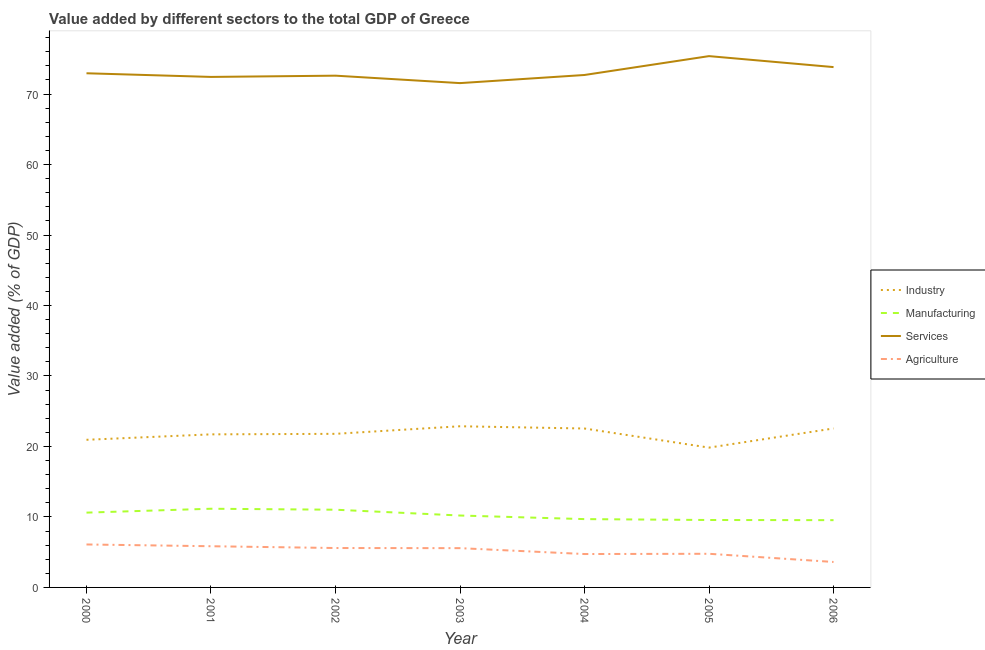Does the line corresponding to value added by manufacturing sector intersect with the line corresponding to value added by industrial sector?
Offer a terse response. No. Is the number of lines equal to the number of legend labels?
Provide a short and direct response. Yes. What is the value added by services sector in 2006?
Your response must be concise. 73.83. Across all years, what is the maximum value added by manufacturing sector?
Your response must be concise. 11.17. Across all years, what is the minimum value added by manufacturing sector?
Offer a terse response. 9.55. In which year was the value added by industrial sector maximum?
Offer a very short reply. 2003. In which year was the value added by manufacturing sector minimum?
Ensure brevity in your answer.  2006. What is the total value added by manufacturing sector in the graph?
Your response must be concise. 71.82. What is the difference between the value added by manufacturing sector in 2000 and that in 2001?
Your response must be concise. -0.55. What is the difference between the value added by manufacturing sector in 2000 and the value added by industrial sector in 2005?
Keep it short and to the point. -9.22. What is the average value added by industrial sector per year?
Provide a short and direct response. 21.75. In the year 2004, what is the difference between the value added by industrial sector and value added by manufacturing sector?
Provide a succinct answer. 12.85. What is the ratio of the value added by manufacturing sector in 2000 to that in 2002?
Provide a short and direct response. 0.96. What is the difference between the highest and the second highest value added by manufacturing sector?
Make the answer very short. 0.14. What is the difference between the highest and the lowest value added by manufacturing sector?
Offer a very short reply. 1.62. In how many years, is the value added by industrial sector greater than the average value added by industrial sector taken over all years?
Make the answer very short. 4. Is it the case that in every year, the sum of the value added by industrial sector and value added by manufacturing sector is greater than the value added by services sector?
Provide a succinct answer. No. Does the value added by services sector monotonically increase over the years?
Keep it short and to the point. No. How many lines are there?
Your answer should be compact. 4. How many years are there in the graph?
Make the answer very short. 7. What is the difference between two consecutive major ticks on the Y-axis?
Keep it short and to the point. 10. Are the values on the major ticks of Y-axis written in scientific E-notation?
Make the answer very short. No. Where does the legend appear in the graph?
Keep it short and to the point. Center right. What is the title of the graph?
Offer a terse response. Value added by different sectors to the total GDP of Greece. What is the label or title of the Y-axis?
Offer a terse response. Value added (% of GDP). What is the Value added (% of GDP) in Industry in 2000?
Provide a short and direct response. 20.95. What is the Value added (% of GDP) in Manufacturing in 2000?
Offer a terse response. 10.61. What is the Value added (% of GDP) in Services in 2000?
Your answer should be very brief. 72.96. What is the Value added (% of GDP) in Agriculture in 2000?
Offer a terse response. 6.1. What is the Value added (% of GDP) of Industry in 2001?
Give a very brief answer. 21.72. What is the Value added (% of GDP) of Manufacturing in 2001?
Make the answer very short. 11.17. What is the Value added (% of GDP) in Services in 2001?
Keep it short and to the point. 72.44. What is the Value added (% of GDP) of Agriculture in 2001?
Make the answer very short. 5.84. What is the Value added (% of GDP) in Industry in 2002?
Your answer should be very brief. 21.79. What is the Value added (% of GDP) in Manufacturing in 2002?
Ensure brevity in your answer.  11.03. What is the Value added (% of GDP) of Services in 2002?
Your response must be concise. 72.61. What is the Value added (% of GDP) in Agriculture in 2002?
Give a very brief answer. 5.59. What is the Value added (% of GDP) in Industry in 2003?
Provide a short and direct response. 22.87. What is the Value added (% of GDP) in Manufacturing in 2003?
Your answer should be compact. 10.2. What is the Value added (% of GDP) of Services in 2003?
Give a very brief answer. 71.56. What is the Value added (% of GDP) in Agriculture in 2003?
Make the answer very short. 5.57. What is the Value added (% of GDP) in Industry in 2004?
Your answer should be very brief. 22.55. What is the Value added (% of GDP) in Manufacturing in 2004?
Your answer should be compact. 9.69. What is the Value added (% of GDP) of Services in 2004?
Give a very brief answer. 72.71. What is the Value added (% of GDP) in Agriculture in 2004?
Keep it short and to the point. 4.74. What is the Value added (% of GDP) of Industry in 2005?
Ensure brevity in your answer.  19.84. What is the Value added (% of GDP) in Manufacturing in 2005?
Provide a short and direct response. 9.57. What is the Value added (% of GDP) of Services in 2005?
Provide a succinct answer. 75.39. What is the Value added (% of GDP) in Agriculture in 2005?
Make the answer very short. 4.77. What is the Value added (% of GDP) of Industry in 2006?
Make the answer very short. 22.56. What is the Value added (% of GDP) in Manufacturing in 2006?
Offer a very short reply. 9.55. What is the Value added (% of GDP) of Services in 2006?
Your answer should be very brief. 73.83. What is the Value added (% of GDP) in Agriculture in 2006?
Offer a terse response. 3.61. Across all years, what is the maximum Value added (% of GDP) of Industry?
Keep it short and to the point. 22.87. Across all years, what is the maximum Value added (% of GDP) of Manufacturing?
Provide a succinct answer. 11.17. Across all years, what is the maximum Value added (% of GDP) in Services?
Ensure brevity in your answer.  75.39. Across all years, what is the maximum Value added (% of GDP) of Agriculture?
Keep it short and to the point. 6.1. Across all years, what is the minimum Value added (% of GDP) in Industry?
Ensure brevity in your answer.  19.84. Across all years, what is the minimum Value added (% of GDP) in Manufacturing?
Your answer should be compact. 9.55. Across all years, what is the minimum Value added (% of GDP) of Services?
Your answer should be very brief. 71.56. Across all years, what is the minimum Value added (% of GDP) in Agriculture?
Offer a terse response. 3.61. What is the total Value added (% of GDP) in Industry in the graph?
Offer a terse response. 152.27. What is the total Value added (% of GDP) of Manufacturing in the graph?
Your answer should be compact. 71.82. What is the total Value added (% of GDP) in Services in the graph?
Your answer should be compact. 511.5. What is the total Value added (% of GDP) of Agriculture in the graph?
Ensure brevity in your answer.  36.23. What is the difference between the Value added (% of GDP) of Industry in 2000 and that in 2001?
Provide a succinct answer. -0.77. What is the difference between the Value added (% of GDP) of Manufacturing in 2000 and that in 2001?
Give a very brief answer. -0.55. What is the difference between the Value added (% of GDP) in Services in 2000 and that in 2001?
Offer a very short reply. 0.52. What is the difference between the Value added (% of GDP) of Agriculture in 2000 and that in 2001?
Give a very brief answer. 0.25. What is the difference between the Value added (% of GDP) of Industry in 2000 and that in 2002?
Ensure brevity in your answer.  -0.85. What is the difference between the Value added (% of GDP) in Manufacturing in 2000 and that in 2002?
Ensure brevity in your answer.  -0.41. What is the difference between the Value added (% of GDP) in Services in 2000 and that in 2002?
Keep it short and to the point. 0.34. What is the difference between the Value added (% of GDP) in Agriculture in 2000 and that in 2002?
Make the answer very short. 0.5. What is the difference between the Value added (% of GDP) of Industry in 2000 and that in 2003?
Offer a terse response. -1.92. What is the difference between the Value added (% of GDP) in Manufacturing in 2000 and that in 2003?
Your response must be concise. 0.41. What is the difference between the Value added (% of GDP) in Services in 2000 and that in 2003?
Offer a terse response. 1.4. What is the difference between the Value added (% of GDP) in Agriculture in 2000 and that in 2003?
Give a very brief answer. 0.52. What is the difference between the Value added (% of GDP) in Industry in 2000 and that in 2004?
Your answer should be compact. -1.6. What is the difference between the Value added (% of GDP) in Manufacturing in 2000 and that in 2004?
Your response must be concise. 0.92. What is the difference between the Value added (% of GDP) in Services in 2000 and that in 2004?
Your response must be concise. 0.24. What is the difference between the Value added (% of GDP) in Agriculture in 2000 and that in 2004?
Your answer should be compact. 1.36. What is the difference between the Value added (% of GDP) in Industry in 2000 and that in 2005?
Make the answer very short. 1.11. What is the difference between the Value added (% of GDP) in Manufacturing in 2000 and that in 2005?
Provide a short and direct response. 1.05. What is the difference between the Value added (% of GDP) of Services in 2000 and that in 2005?
Ensure brevity in your answer.  -2.43. What is the difference between the Value added (% of GDP) of Agriculture in 2000 and that in 2005?
Offer a terse response. 1.32. What is the difference between the Value added (% of GDP) of Industry in 2000 and that in 2006?
Your answer should be compact. -1.61. What is the difference between the Value added (% of GDP) of Manufacturing in 2000 and that in 2006?
Your response must be concise. 1.07. What is the difference between the Value added (% of GDP) of Services in 2000 and that in 2006?
Keep it short and to the point. -0.87. What is the difference between the Value added (% of GDP) of Agriculture in 2000 and that in 2006?
Your response must be concise. 2.48. What is the difference between the Value added (% of GDP) of Industry in 2001 and that in 2002?
Ensure brevity in your answer.  -0.07. What is the difference between the Value added (% of GDP) in Manufacturing in 2001 and that in 2002?
Offer a very short reply. 0.14. What is the difference between the Value added (% of GDP) in Services in 2001 and that in 2002?
Your answer should be very brief. -0.18. What is the difference between the Value added (% of GDP) of Agriculture in 2001 and that in 2002?
Offer a very short reply. 0.25. What is the difference between the Value added (% of GDP) in Industry in 2001 and that in 2003?
Keep it short and to the point. -1.15. What is the difference between the Value added (% of GDP) of Manufacturing in 2001 and that in 2003?
Keep it short and to the point. 0.96. What is the difference between the Value added (% of GDP) of Services in 2001 and that in 2003?
Ensure brevity in your answer.  0.88. What is the difference between the Value added (% of GDP) in Agriculture in 2001 and that in 2003?
Provide a short and direct response. 0.27. What is the difference between the Value added (% of GDP) of Industry in 2001 and that in 2004?
Provide a short and direct response. -0.83. What is the difference between the Value added (% of GDP) of Manufacturing in 2001 and that in 2004?
Give a very brief answer. 1.47. What is the difference between the Value added (% of GDP) of Services in 2001 and that in 2004?
Your response must be concise. -0.28. What is the difference between the Value added (% of GDP) of Agriculture in 2001 and that in 2004?
Keep it short and to the point. 1.11. What is the difference between the Value added (% of GDP) of Industry in 2001 and that in 2005?
Offer a very short reply. 1.88. What is the difference between the Value added (% of GDP) of Manufacturing in 2001 and that in 2005?
Your answer should be very brief. 1.6. What is the difference between the Value added (% of GDP) in Services in 2001 and that in 2005?
Make the answer very short. -2.95. What is the difference between the Value added (% of GDP) of Agriculture in 2001 and that in 2005?
Your answer should be compact. 1.07. What is the difference between the Value added (% of GDP) of Industry in 2001 and that in 2006?
Keep it short and to the point. -0.84. What is the difference between the Value added (% of GDP) in Manufacturing in 2001 and that in 2006?
Provide a short and direct response. 1.62. What is the difference between the Value added (% of GDP) in Services in 2001 and that in 2006?
Make the answer very short. -1.4. What is the difference between the Value added (% of GDP) in Agriculture in 2001 and that in 2006?
Your answer should be compact. 2.23. What is the difference between the Value added (% of GDP) of Industry in 2002 and that in 2003?
Provide a short and direct response. -1.07. What is the difference between the Value added (% of GDP) of Manufacturing in 2002 and that in 2003?
Your answer should be very brief. 0.82. What is the difference between the Value added (% of GDP) in Services in 2002 and that in 2003?
Your answer should be very brief. 1.06. What is the difference between the Value added (% of GDP) in Agriculture in 2002 and that in 2003?
Ensure brevity in your answer.  0.02. What is the difference between the Value added (% of GDP) in Industry in 2002 and that in 2004?
Make the answer very short. -0.76. What is the difference between the Value added (% of GDP) in Manufacturing in 2002 and that in 2004?
Your response must be concise. 1.33. What is the difference between the Value added (% of GDP) of Services in 2002 and that in 2004?
Provide a succinct answer. -0.1. What is the difference between the Value added (% of GDP) of Agriculture in 2002 and that in 2004?
Your answer should be very brief. 0.85. What is the difference between the Value added (% of GDP) of Industry in 2002 and that in 2005?
Ensure brevity in your answer.  1.96. What is the difference between the Value added (% of GDP) in Manufacturing in 2002 and that in 2005?
Offer a very short reply. 1.46. What is the difference between the Value added (% of GDP) in Services in 2002 and that in 2005?
Give a very brief answer. -2.77. What is the difference between the Value added (% of GDP) in Agriculture in 2002 and that in 2005?
Your answer should be very brief. 0.82. What is the difference between the Value added (% of GDP) in Industry in 2002 and that in 2006?
Your answer should be compact. -0.76. What is the difference between the Value added (% of GDP) of Manufacturing in 2002 and that in 2006?
Give a very brief answer. 1.48. What is the difference between the Value added (% of GDP) of Services in 2002 and that in 2006?
Ensure brevity in your answer.  -1.22. What is the difference between the Value added (% of GDP) in Agriculture in 2002 and that in 2006?
Ensure brevity in your answer.  1.98. What is the difference between the Value added (% of GDP) in Industry in 2003 and that in 2004?
Offer a terse response. 0.32. What is the difference between the Value added (% of GDP) of Manufacturing in 2003 and that in 2004?
Offer a terse response. 0.51. What is the difference between the Value added (% of GDP) of Services in 2003 and that in 2004?
Make the answer very short. -1.15. What is the difference between the Value added (% of GDP) in Agriculture in 2003 and that in 2004?
Your response must be concise. 0.83. What is the difference between the Value added (% of GDP) in Industry in 2003 and that in 2005?
Your answer should be very brief. 3.03. What is the difference between the Value added (% of GDP) in Manufacturing in 2003 and that in 2005?
Your answer should be compact. 0.64. What is the difference between the Value added (% of GDP) of Services in 2003 and that in 2005?
Give a very brief answer. -3.83. What is the difference between the Value added (% of GDP) in Agriculture in 2003 and that in 2005?
Make the answer very short. 0.8. What is the difference between the Value added (% of GDP) of Industry in 2003 and that in 2006?
Make the answer very short. 0.31. What is the difference between the Value added (% of GDP) of Manufacturing in 2003 and that in 2006?
Your answer should be very brief. 0.66. What is the difference between the Value added (% of GDP) of Services in 2003 and that in 2006?
Provide a succinct answer. -2.27. What is the difference between the Value added (% of GDP) in Agriculture in 2003 and that in 2006?
Provide a succinct answer. 1.96. What is the difference between the Value added (% of GDP) of Industry in 2004 and that in 2005?
Your response must be concise. 2.71. What is the difference between the Value added (% of GDP) of Manufacturing in 2004 and that in 2005?
Offer a very short reply. 0.13. What is the difference between the Value added (% of GDP) of Services in 2004 and that in 2005?
Offer a very short reply. -2.68. What is the difference between the Value added (% of GDP) in Agriculture in 2004 and that in 2005?
Give a very brief answer. -0.03. What is the difference between the Value added (% of GDP) in Industry in 2004 and that in 2006?
Offer a terse response. -0.01. What is the difference between the Value added (% of GDP) in Manufacturing in 2004 and that in 2006?
Ensure brevity in your answer.  0.15. What is the difference between the Value added (% of GDP) in Services in 2004 and that in 2006?
Your answer should be very brief. -1.12. What is the difference between the Value added (% of GDP) of Agriculture in 2004 and that in 2006?
Offer a terse response. 1.13. What is the difference between the Value added (% of GDP) in Industry in 2005 and that in 2006?
Give a very brief answer. -2.72. What is the difference between the Value added (% of GDP) of Manufacturing in 2005 and that in 2006?
Your answer should be very brief. 0.02. What is the difference between the Value added (% of GDP) in Services in 2005 and that in 2006?
Provide a short and direct response. 1.56. What is the difference between the Value added (% of GDP) in Agriculture in 2005 and that in 2006?
Ensure brevity in your answer.  1.16. What is the difference between the Value added (% of GDP) of Industry in 2000 and the Value added (% of GDP) of Manufacturing in 2001?
Your answer should be very brief. 9.78. What is the difference between the Value added (% of GDP) of Industry in 2000 and the Value added (% of GDP) of Services in 2001?
Provide a succinct answer. -51.49. What is the difference between the Value added (% of GDP) in Industry in 2000 and the Value added (% of GDP) in Agriculture in 2001?
Your answer should be very brief. 15.1. What is the difference between the Value added (% of GDP) of Manufacturing in 2000 and the Value added (% of GDP) of Services in 2001?
Offer a very short reply. -61.82. What is the difference between the Value added (% of GDP) in Manufacturing in 2000 and the Value added (% of GDP) in Agriculture in 2001?
Give a very brief answer. 4.77. What is the difference between the Value added (% of GDP) in Services in 2000 and the Value added (% of GDP) in Agriculture in 2001?
Offer a terse response. 67.11. What is the difference between the Value added (% of GDP) in Industry in 2000 and the Value added (% of GDP) in Manufacturing in 2002?
Make the answer very short. 9.92. What is the difference between the Value added (% of GDP) of Industry in 2000 and the Value added (% of GDP) of Services in 2002?
Offer a very short reply. -51.67. What is the difference between the Value added (% of GDP) of Industry in 2000 and the Value added (% of GDP) of Agriculture in 2002?
Your answer should be very brief. 15.36. What is the difference between the Value added (% of GDP) in Manufacturing in 2000 and the Value added (% of GDP) in Services in 2002?
Your answer should be very brief. -62. What is the difference between the Value added (% of GDP) in Manufacturing in 2000 and the Value added (% of GDP) in Agriculture in 2002?
Your response must be concise. 5.02. What is the difference between the Value added (% of GDP) in Services in 2000 and the Value added (% of GDP) in Agriculture in 2002?
Make the answer very short. 67.36. What is the difference between the Value added (% of GDP) of Industry in 2000 and the Value added (% of GDP) of Manufacturing in 2003?
Offer a terse response. 10.74. What is the difference between the Value added (% of GDP) in Industry in 2000 and the Value added (% of GDP) in Services in 2003?
Provide a succinct answer. -50.61. What is the difference between the Value added (% of GDP) in Industry in 2000 and the Value added (% of GDP) in Agriculture in 2003?
Keep it short and to the point. 15.38. What is the difference between the Value added (% of GDP) of Manufacturing in 2000 and the Value added (% of GDP) of Services in 2003?
Keep it short and to the point. -60.94. What is the difference between the Value added (% of GDP) in Manufacturing in 2000 and the Value added (% of GDP) in Agriculture in 2003?
Your answer should be compact. 5.04. What is the difference between the Value added (% of GDP) in Services in 2000 and the Value added (% of GDP) in Agriculture in 2003?
Keep it short and to the point. 67.38. What is the difference between the Value added (% of GDP) of Industry in 2000 and the Value added (% of GDP) of Manufacturing in 2004?
Your answer should be compact. 11.25. What is the difference between the Value added (% of GDP) of Industry in 2000 and the Value added (% of GDP) of Services in 2004?
Provide a short and direct response. -51.76. What is the difference between the Value added (% of GDP) in Industry in 2000 and the Value added (% of GDP) in Agriculture in 2004?
Your answer should be very brief. 16.21. What is the difference between the Value added (% of GDP) of Manufacturing in 2000 and the Value added (% of GDP) of Services in 2004?
Make the answer very short. -62.1. What is the difference between the Value added (% of GDP) of Manufacturing in 2000 and the Value added (% of GDP) of Agriculture in 2004?
Keep it short and to the point. 5.88. What is the difference between the Value added (% of GDP) of Services in 2000 and the Value added (% of GDP) of Agriculture in 2004?
Provide a short and direct response. 68.22. What is the difference between the Value added (% of GDP) of Industry in 2000 and the Value added (% of GDP) of Manufacturing in 2005?
Make the answer very short. 11.38. What is the difference between the Value added (% of GDP) in Industry in 2000 and the Value added (% of GDP) in Services in 2005?
Give a very brief answer. -54.44. What is the difference between the Value added (% of GDP) of Industry in 2000 and the Value added (% of GDP) of Agriculture in 2005?
Your response must be concise. 16.17. What is the difference between the Value added (% of GDP) in Manufacturing in 2000 and the Value added (% of GDP) in Services in 2005?
Keep it short and to the point. -64.77. What is the difference between the Value added (% of GDP) in Manufacturing in 2000 and the Value added (% of GDP) in Agriculture in 2005?
Provide a short and direct response. 5.84. What is the difference between the Value added (% of GDP) in Services in 2000 and the Value added (% of GDP) in Agriculture in 2005?
Ensure brevity in your answer.  68.18. What is the difference between the Value added (% of GDP) in Industry in 2000 and the Value added (% of GDP) in Manufacturing in 2006?
Provide a short and direct response. 11.4. What is the difference between the Value added (% of GDP) of Industry in 2000 and the Value added (% of GDP) of Services in 2006?
Your response must be concise. -52.88. What is the difference between the Value added (% of GDP) in Industry in 2000 and the Value added (% of GDP) in Agriculture in 2006?
Give a very brief answer. 17.34. What is the difference between the Value added (% of GDP) of Manufacturing in 2000 and the Value added (% of GDP) of Services in 2006?
Make the answer very short. -63.22. What is the difference between the Value added (% of GDP) in Manufacturing in 2000 and the Value added (% of GDP) in Agriculture in 2006?
Keep it short and to the point. 7. What is the difference between the Value added (% of GDP) of Services in 2000 and the Value added (% of GDP) of Agriculture in 2006?
Your response must be concise. 69.34. What is the difference between the Value added (% of GDP) of Industry in 2001 and the Value added (% of GDP) of Manufacturing in 2002?
Your answer should be very brief. 10.69. What is the difference between the Value added (% of GDP) in Industry in 2001 and the Value added (% of GDP) in Services in 2002?
Your response must be concise. -50.9. What is the difference between the Value added (% of GDP) in Industry in 2001 and the Value added (% of GDP) in Agriculture in 2002?
Provide a short and direct response. 16.13. What is the difference between the Value added (% of GDP) of Manufacturing in 2001 and the Value added (% of GDP) of Services in 2002?
Your answer should be compact. -61.45. What is the difference between the Value added (% of GDP) in Manufacturing in 2001 and the Value added (% of GDP) in Agriculture in 2002?
Your answer should be very brief. 5.57. What is the difference between the Value added (% of GDP) in Services in 2001 and the Value added (% of GDP) in Agriculture in 2002?
Offer a very short reply. 66.84. What is the difference between the Value added (% of GDP) of Industry in 2001 and the Value added (% of GDP) of Manufacturing in 2003?
Make the answer very short. 11.52. What is the difference between the Value added (% of GDP) in Industry in 2001 and the Value added (% of GDP) in Services in 2003?
Keep it short and to the point. -49.84. What is the difference between the Value added (% of GDP) of Industry in 2001 and the Value added (% of GDP) of Agriculture in 2003?
Make the answer very short. 16.15. What is the difference between the Value added (% of GDP) of Manufacturing in 2001 and the Value added (% of GDP) of Services in 2003?
Make the answer very short. -60.39. What is the difference between the Value added (% of GDP) of Manufacturing in 2001 and the Value added (% of GDP) of Agriculture in 2003?
Give a very brief answer. 5.59. What is the difference between the Value added (% of GDP) in Services in 2001 and the Value added (% of GDP) in Agriculture in 2003?
Provide a succinct answer. 66.86. What is the difference between the Value added (% of GDP) in Industry in 2001 and the Value added (% of GDP) in Manufacturing in 2004?
Offer a very short reply. 12.03. What is the difference between the Value added (% of GDP) of Industry in 2001 and the Value added (% of GDP) of Services in 2004?
Offer a very short reply. -50.99. What is the difference between the Value added (% of GDP) of Industry in 2001 and the Value added (% of GDP) of Agriculture in 2004?
Provide a succinct answer. 16.98. What is the difference between the Value added (% of GDP) of Manufacturing in 2001 and the Value added (% of GDP) of Services in 2004?
Your answer should be very brief. -61.55. What is the difference between the Value added (% of GDP) of Manufacturing in 2001 and the Value added (% of GDP) of Agriculture in 2004?
Ensure brevity in your answer.  6.43. What is the difference between the Value added (% of GDP) in Services in 2001 and the Value added (% of GDP) in Agriculture in 2004?
Offer a very short reply. 67.7. What is the difference between the Value added (% of GDP) in Industry in 2001 and the Value added (% of GDP) in Manufacturing in 2005?
Your response must be concise. 12.15. What is the difference between the Value added (% of GDP) in Industry in 2001 and the Value added (% of GDP) in Services in 2005?
Provide a short and direct response. -53.67. What is the difference between the Value added (% of GDP) of Industry in 2001 and the Value added (% of GDP) of Agriculture in 2005?
Offer a terse response. 16.95. What is the difference between the Value added (% of GDP) of Manufacturing in 2001 and the Value added (% of GDP) of Services in 2005?
Ensure brevity in your answer.  -64.22. What is the difference between the Value added (% of GDP) in Manufacturing in 2001 and the Value added (% of GDP) in Agriculture in 2005?
Provide a succinct answer. 6.39. What is the difference between the Value added (% of GDP) of Services in 2001 and the Value added (% of GDP) of Agriculture in 2005?
Your response must be concise. 67.66. What is the difference between the Value added (% of GDP) in Industry in 2001 and the Value added (% of GDP) in Manufacturing in 2006?
Keep it short and to the point. 12.17. What is the difference between the Value added (% of GDP) in Industry in 2001 and the Value added (% of GDP) in Services in 2006?
Your response must be concise. -52.11. What is the difference between the Value added (% of GDP) of Industry in 2001 and the Value added (% of GDP) of Agriculture in 2006?
Your answer should be compact. 18.11. What is the difference between the Value added (% of GDP) in Manufacturing in 2001 and the Value added (% of GDP) in Services in 2006?
Offer a terse response. -62.66. What is the difference between the Value added (% of GDP) of Manufacturing in 2001 and the Value added (% of GDP) of Agriculture in 2006?
Offer a very short reply. 7.55. What is the difference between the Value added (% of GDP) of Services in 2001 and the Value added (% of GDP) of Agriculture in 2006?
Provide a short and direct response. 68.82. What is the difference between the Value added (% of GDP) in Industry in 2002 and the Value added (% of GDP) in Manufacturing in 2003?
Keep it short and to the point. 11.59. What is the difference between the Value added (% of GDP) of Industry in 2002 and the Value added (% of GDP) of Services in 2003?
Provide a succinct answer. -49.77. What is the difference between the Value added (% of GDP) in Industry in 2002 and the Value added (% of GDP) in Agriculture in 2003?
Offer a terse response. 16.22. What is the difference between the Value added (% of GDP) of Manufacturing in 2002 and the Value added (% of GDP) of Services in 2003?
Provide a succinct answer. -60.53. What is the difference between the Value added (% of GDP) of Manufacturing in 2002 and the Value added (% of GDP) of Agriculture in 2003?
Your response must be concise. 5.45. What is the difference between the Value added (% of GDP) in Services in 2002 and the Value added (% of GDP) in Agriculture in 2003?
Provide a short and direct response. 67.04. What is the difference between the Value added (% of GDP) of Industry in 2002 and the Value added (% of GDP) of Manufacturing in 2004?
Your answer should be very brief. 12.1. What is the difference between the Value added (% of GDP) in Industry in 2002 and the Value added (% of GDP) in Services in 2004?
Ensure brevity in your answer.  -50.92. What is the difference between the Value added (% of GDP) in Industry in 2002 and the Value added (% of GDP) in Agriculture in 2004?
Make the answer very short. 17.05. What is the difference between the Value added (% of GDP) of Manufacturing in 2002 and the Value added (% of GDP) of Services in 2004?
Offer a very short reply. -61.68. What is the difference between the Value added (% of GDP) in Manufacturing in 2002 and the Value added (% of GDP) in Agriculture in 2004?
Ensure brevity in your answer.  6.29. What is the difference between the Value added (% of GDP) in Services in 2002 and the Value added (% of GDP) in Agriculture in 2004?
Make the answer very short. 67.88. What is the difference between the Value added (% of GDP) in Industry in 2002 and the Value added (% of GDP) in Manufacturing in 2005?
Ensure brevity in your answer.  12.23. What is the difference between the Value added (% of GDP) in Industry in 2002 and the Value added (% of GDP) in Services in 2005?
Give a very brief answer. -53.59. What is the difference between the Value added (% of GDP) of Industry in 2002 and the Value added (% of GDP) of Agriculture in 2005?
Give a very brief answer. 17.02. What is the difference between the Value added (% of GDP) in Manufacturing in 2002 and the Value added (% of GDP) in Services in 2005?
Provide a short and direct response. -64.36. What is the difference between the Value added (% of GDP) of Manufacturing in 2002 and the Value added (% of GDP) of Agriculture in 2005?
Offer a very short reply. 6.25. What is the difference between the Value added (% of GDP) of Services in 2002 and the Value added (% of GDP) of Agriculture in 2005?
Provide a short and direct response. 67.84. What is the difference between the Value added (% of GDP) of Industry in 2002 and the Value added (% of GDP) of Manufacturing in 2006?
Give a very brief answer. 12.25. What is the difference between the Value added (% of GDP) of Industry in 2002 and the Value added (% of GDP) of Services in 2006?
Make the answer very short. -52.04. What is the difference between the Value added (% of GDP) of Industry in 2002 and the Value added (% of GDP) of Agriculture in 2006?
Your answer should be very brief. 18.18. What is the difference between the Value added (% of GDP) in Manufacturing in 2002 and the Value added (% of GDP) in Services in 2006?
Provide a short and direct response. -62.8. What is the difference between the Value added (% of GDP) in Manufacturing in 2002 and the Value added (% of GDP) in Agriculture in 2006?
Provide a short and direct response. 7.41. What is the difference between the Value added (% of GDP) of Services in 2002 and the Value added (% of GDP) of Agriculture in 2006?
Give a very brief answer. 69. What is the difference between the Value added (% of GDP) in Industry in 2003 and the Value added (% of GDP) in Manufacturing in 2004?
Offer a very short reply. 13.17. What is the difference between the Value added (% of GDP) in Industry in 2003 and the Value added (% of GDP) in Services in 2004?
Provide a succinct answer. -49.84. What is the difference between the Value added (% of GDP) in Industry in 2003 and the Value added (% of GDP) in Agriculture in 2004?
Offer a very short reply. 18.13. What is the difference between the Value added (% of GDP) in Manufacturing in 2003 and the Value added (% of GDP) in Services in 2004?
Give a very brief answer. -62.51. What is the difference between the Value added (% of GDP) in Manufacturing in 2003 and the Value added (% of GDP) in Agriculture in 2004?
Your response must be concise. 5.46. What is the difference between the Value added (% of GDP) of Services in 2003 and the Value added (% of GDP) of Agriculture in 2004?
Make the answer very short. 66.82. What is the difference between the Value added (% of GDP) in Industry in 2003 and the Value added (% of GDP) in Manufacturing in 2005?
Provide a succinct answer. 13.3. What is the difference between the Value added (% of GDP) of Industry in 2003 and the Value added (% of GDP) of Services in 2005?
Offer a terse response. -52.52. What is the difference between the Value added (% of GDP) in Industry in 2003 and the Value added (% of GDP) in Agriculture in 2005?
Your response must be concise. 18.09. What is the difference between the Value added (% of GDP) in Manufacturing in 2003 and the Value added (% of GDP) in Services in 2005?
Your answer should be compact. -65.18. What is the difference between the Value added (% of GDP) in Manufacturing in 2003 and the Value added (% of GDP) in Agriculture in 2005?
Provide a succinct answer. 5.43. What is the difference between the Value added (% of GDP) in Services in 2003 and the Value added (% of GDP) in Agriculture in 2005?
Provide a succinct answer. 66.79. What is the difference between the Value added (% of GDP) in Industry in 2003 and the Value added (% of GDP) in Manufacturing in 2006?
Ensure brevity in your answer.  13.32. What is the difference between the Value added (% of GDP) of Industry in 2003 and the Value added (% of GDP) of Services in 2006?
Your response must be concise. -50.96. What is the difference between the Value added (% of GDP) in Industry in 2003 and the Value added (% of GDP) in Agriculture in 2006?
Your answer should be very brief. 19.26. What is the difference between the Value added (% of GDP) of Manufacturing in 2003 and the Value added (% of GDP) of Services in 2006?
Give a very brief answer. -63.63. What is the difference between the Value added (% of GDP) in Manufacturing in 2003 and the Value added (% of GDP) in Agriculture in 2006?
Ensure brevity in your answer.  6.59. What is the difference between the Value added (% of GDP) of Services in 2003 and the Value added (% of GDP) of Agriculture in 2006?
Offer a very short reply. 67.95. What is the difference between the Value added (% of GDP) of Industry in 2004 and the Value added (% of GDP) of Manufacturing in 2005?
Your answer should be very brief. 12.98. What is the difference between the Value added (% of GDP) of Industry in 2004 and the Value added (% of GDP) of Services in 2005?
Ensure brevity in your answer.  -52.84. What is the difference between the Value added (% of GDP) of Industry in 2004 and the Value added (% of GDP) of Agriculture in 2005?
Offer a very short reply. 17.78. What is the difference between the Value added (% of GDP) in Manufacturing in 2004 and the Value added (% of GDP) in Services in 2005?
Give a very brief answer. -65.69. What is the difference between the Value added (% of GDP) of Manufacturing in 2004 and the Value added (% of GDP) of Agriculture in 2005?
Make the answer very short. 4.92. What is the difference between the Value added (% of GDP) of Services in 2004 and the Value added (% of GDP) of Agriculture in 2005?
Provide a short and direct response. 67.94. What is the difference between the Value added (% of GDP) in Industry in 2004 and the Value added (% of GDP) in Manufacturing in 2006?
Your response must be concise. 13. What is the difference between the Value added (% of GDP) of Industry in 2004 and the Value added (% of GDP) of Services in 2006?
Make the answer very short. -51.28. What is the difference between the Value added (% of GDP) in Industry in 2004 and the Value added (% of GDP) in Agriculture in 2006?
Ensure brevity in your answer.  18.94. What is the difference between the Value added (% of GDP) of Manufacturing in 2004 and the Value added (% of GDP) of Services in 2006?
Keep it short and to the point. -64.14. What is the difference between the Value added (% of GDP) of Manufacturing in 2004 and the Value added (% of GDP) of Agriculture in 2006?
Offer a terse response. 6.08. What is the difference between the Value added (% of GDP) in Services in 2004 and the Value added (% of GDP) in Agriculture in 2006?
Ensure brevity in your answer.  69.1. What is the difference between the Value added (% of GDP) of Industry in 2005 and the Value added (% of GDP) of Manufacturing in 2006?
Offer a terse response. 10.29. What is the difference between the Value added (% of GDP) in Industry in 2005 and the Value added (% of GDP) in Services in 2006?
Give a very brief answer. -53.99. What is the difference between the Value added (% of GDP) of Industry in 2005 and the Value added (% of GDP) of Agriculture in 2006?
Offer a very short reply. 16.23. What is the difference between the Value added (% of GDP) in Manufacturing in 2005 and the Value added (% of GDP) in Services in 2006?
Your response must be concise. -64.26. What is the difference between the Value added (% of GDP) of Manufacturing in 2005 and the Value added (% of GDP) of Agriculture in 2006?
Ensure brevity in your answer.  5.95. What is the difference between the Value added (% of GDP) of Services in 2005 and the Value added (% of GDP) of Agriculture in 2006?
Keep it short and to the point. 71.78. What is the average Value added (% of GDP) in Industry per year?
Ensure brevity in your answer.  21.75. What is the average Value added (% of GDP) of Manufacturing per year?
Offer a very short reply. 10.26. What is the average Value added (% of GDP) in Services per year?
Provide a short and direct response. 73.07. What is the average Value added (% of GDP) in Agriculture per year?
Your answer should be very brief. 5.18. In the year 2000, what is the difference between the Value added (% of GDP) of Industry and Value added (% of GDP) of Manufacturing?
Give a very brief answer. 10.33. In the year 2000, what is the difference between the Value added (% of GDP) of Industry and Value added (% of GDP) of Services?
Give a very brief answer. -52.01. In the year 2000, what is the difference between the Value added (% of GDP) of Industry and Value added (% of GDP) of Agriculture?
Keep it short and to the point. 14.85. In the year 2000, what is the difference between the Value added (% of GDP) of Manufacturing and Value added (% of GDP) of Services?
Offer a very short reply. -62.34. In the year 2000, what is the difference between the Value added (% of GDP) of Manufacturing and Value added (% of GDP) of Agriculture?
Provide a succinct answer. 4.52. In the year 2000, what is the difference between the Value added (% of GDP) of Services and Value added (% of GDP) of Agriculture?
Your response must be concise. 66.86. In the year 2001, what is the difference between the Value added (% of GDP) in Industry and Value added (% of GDP) in Manufacturing?
Your answer should be very brief. 10.55. In the year 2001, what is the difference between the Value added (% of GDP) in Industry and Value added (% of GDP) in Services?
Offer a very short reply. -50.72. In the year 2001, what is the difference between the Value added (% of GDP) in Industry and Value added (% of GDP) in Agriculture?
Provide a short and direct response. 15.87. In the year 2001, what is the difference between the Value added (% of GDP) in Manufacturing and Value added (% of GDP) in Services?
Give a very brief answer. -61.27. In the year 2001, what is the difference between the Value added (% of GDP) of Manufacturing and Value added (% of GDP) of Agriculture?
Your answer should be compact. 5.32. In the year 2001, what is the difference between the Value added (% of GDP) of Services and Value added (% of GDP) of Agriculture?
Give a very brief answer. 66.59. In the year 2002, what is the difference between the Value added (% of GDP) in Industry and Value added (% of GDP) in Manufacturing?
Offer a very short reply. 10.77. In the year 2002, what is the difference between the Value added (% of GDP) in Industry and Value added (% of GDP) in Services?
Give a very brief answer. -50.82. In the year 2002, what is the difference between the Value added (% of GDP) in Industry and Value added (% of GDP) in Agriculture?
Your answer should be compact. 16.2. In the year 2002, what is the difference between the Value added (% of GDP) in Manufacturing and Value added (% of GDP) in Services?
Your answer should be compact. -61.59. In the year 2002, what is the difference between the Value added (% of GDP) of Manufacturing and Value added (% of GDP) of Agriculture?
Your answer should be compact. 5.44. In the year 2002, what is the difference between the Value added (% of GDP) in Services and Value added (% of GDP) in Agriculture?
Your response must be concise. 67.02. In the year 2003, what is the difference between the Value added (% of GDP) in Industry and Value added (% of GDP) in Manufacturing?
Your answer should be very brief. 12.66. In the year 2003, what is the difference between the Value added (% of GDP) in Industry and Value added (% of GDP) in Services?
Offer a terse response. -48.69. In the year 2003, what is the difference between the Value added (% of GDP) in Industry and Value added (% of GDP) in Agriculture?
Provide a short and direct response. 17.3. In the year 2003, what is the difference between the Value added (% of GDP) in Manufacturing and Value added (% of GDP) in Services?
Offer a very short reply. -61.36. In the year 2003, what is the difference between the Value added (% of GDP) of Manufacturing and Value added (% of GDP) of Agriculture?
Provide a succinct answer. 4.63. In the year 2003, what is the difference between the Value added (% of GDP) of Services and Value added (% of GDP) of Agriculture?
Your response must be concise. 65.99. In the year 2004, what is the difference between the Value added (% of GDP) in Industry and Value added (% of GDP) in Manufacturing?
Make the answer very short. 12.85. In the year 2004, what is the difference between the Value added (% of GDP) in Industry and Value added (% of GDP) in Services?
Provide a short and direct response. -50.16. In the year 2004, what is the difference between the Value added (% of GDP) in Industry and Value added (% of GDP) in Agriculture?
Keep it short and to the point. 17.81. In the year 2004, what is the difference between the Value added (% of GDP) of Manufacturing and Value added (% of GDP) of Services?
Make the answer very short. -63.02. In the year 2004, what is the difference between the Value added (% of GDP) in Manufacturing and Value added (% of GDP) in Agriculture?
Give a very brief answer. 4.96. In the year 2004, what is the difference between the Value added (% of GDP) in Services and Value added (% of GDP) in Agriculture?
Make the answer very short. 67.97. In the year 2005, what is the difference between the Value added (% of GDP) in Industry and Value added (% of GDP) in Manufacturing?
Your response must be concise. 10.27. In the year 2005, what is the difference between the Value added (% of GDP) in Industry and Value added (% of GDP) in Services?
Offer a terse response. -55.55. In the year 2005, what is the difference between the Value added (% of GDP) of Industry and Value added (% of GDP) of Agriculture?
Offer a terse response. 15.06. In the year 2005, what is the difference between the Value added (% of GDP) in Manufacturing and Value added (% of GDP) in Services?
Your answer should be very brief. -65.82. In the year 2005, what is the difference between the Value added (% of GDP) of Manufacturing and Value added (% of GDP) of Agriculture?
Offer a very short reply. 4.79. In the year 2005, what is the difference between the Value added (% of GDP) in Services and Value added (% of GDP) in Agriculture?
Offer a terse response. 70.62. In the year 2006, what is the difference between the Value added (% of GDP) in Industry and Value added (% of GDP) in Manufacturing?
Make the answer very short. 13.01. In the year 2006, what is the difference between the Value added (% of GDP) in Industry and Value added (% of GDP) in Services?
Your answer should be very brief. -51.27. In the year 2006, what is the difference between the Value added (% of GDP) of Industry and Value added (% of GDP) of Agriculture?
Give a very brief answer. 18.94. In the year 2006, what is the difference between the Value added (% of GDP) of Manufacturing and Value added (% of GDP) of Services?
Ensure brevity in your answer.  -64.29. In the year 2006, what is the difference between the Value added (% of GDP) of Manufacturing and Value added (% of GDP) of Agriculture?
Ensure brevity in your answer.  5.93. In the year 2006, what is the difference between the Value added (% of GDP) of Services and Value added (% of GDP) of Agriculture?
Provide a short and direct response. 70.22. What is the ratio of the Value added (% of GDP) of Industry in 2000 to that in 2001?
Give a very brief answer. 0.96. What is the ratio of the Value added (% of GDP) in Manufacturing in 2000 to that in 2001?
Offer a terse response. 0.95. What is the ratio of the Value added (% of GDP) in Agriculture in 2000 to that in 2001?
Provide a short and direct response. 1.04. What is the ratio of the Value added (% of GDP) in Industry in 2000 to that in 2002?
Give a very brief answer. 0.96. What is the ratio of the Value added (% of GDP) in Manufacturing in 2000 to that in 2002?
Offer a very short reply. 0.96. What is the ratio of the Value added (% of GDP) in Services in 2000 to that in 2002?
Give a very brief answer. 1. What is the ratio of the Value added (% of GDP) of Agriculture in 2000 to that in 2002?
Ensure brevity in your answer.  1.09. What is the ratio of the Value added (% of GDP) of Industry in 2000 to that in 2003?
Provide a short and direct response. 0.92. What is the ratio of the Value added (% of GDP) in Manufacturing in 2000 to that in 2003?
Your response must be concise. 1.04. What is the ratio of the Value added (% of GDP) in Services in 2000 to that in 2003?
Provide a short and direct response. 1.02. What is the ratio of the Value added (% of GDP) of Agriculture in 2000 to that in 2003?
Give a very brief answer. 1.09. What is the ratio of the Value added (% of GDP) in Industry in 2000 to that in 2004?
Make the answer very short. 0.93. What is the ratio of the Value added (% of GDP) in Manufacturing in 2000 to that in 2004?
Your response must be concise. 1.09. What is the ratio of the Value added (% of GDP) in Agriculture in 2000 to that in 2004?
Provide a short and direct response. 1.29. What is the ratio of the Value added (% of GDP) of Industry in 2000 to that in 2005?
Ensure brevity in your answer.  1.06. What is the ratio of the Value added (% of GDP) of Manufacturing in 2000 to that in 2005?
Offer a terse response. 1.11. What is the ratio of the Value added (% of GDP) in Agriculture in 2000 to that in 2005?
Your answer should be compact. 1.28. What is the ratio of the Value added (% of GDP) of Industry in 2000 to that in 2006?
Provide a succinct answer. 0.93. What is the ratio of the Value added (% of GDP) of Manufacturing in 2000 to that in 2006?
Make the answer very short. 1.11. What is the ratio of the Value added (% of GDP) in Services in 2000 to that in 2006?
Offer a very short reply. 0.99. What is the ratio of the Value added (% of GDP) in Agriculture in 2000 to that in 2006?
Make the answer very short. 1.69. What is the ratio of the Value added (% of GDP) of Industry in 2001 to that in 2002?
Offer a terse response. 1. What is the ratio of the Value added (% of GDP) in Manufacturing in 2001 to that in 2002?
Keep it short and to the point. 1.01. What is the ratio of the Value added (% of GDP) of Services in 2001 to that in 2002?
Provide a short and direct response. 1. What is the ratio of the Value added (% of GDP) in Agriculture in 2001 to that in 2002?
Give a very brief answer. 1.05. What is the ratio of the Value added (% of GDP) of Industry in 2001 to that in 2003?
Keep it short and to the point. 0.95. What is the ratio of the Value added (% of GDP) in Manufacturing in 2001 to that in 2003?
Your response must be concise. 1.09. What is the ratio of the Value added (% of GDP) of Services in 2001 to that in 2003?
Keep it short and to the point. 1.01. What is the ratio of the Value added (% of GDP) of Agriculture in 2001 to that in 2003?
Give a very brief answer. 1.05. What is the ratio of the Value added (% of GDP) of Industry in 2001 to that in 2004?
Your answer should be very brief. 0.96. What is the ratio of the Value added (% of GDP) in Manufacturing in 2001 to that in 2004?
Offer a terse response. 1.15. What is the ratio of the Value added (% of GDP) of Agriculture in 2001 to that in 2004?
Keep it short and to the point. 1.23. What is the ratio of the Value added (% of GDP) in Industry in 2001 to that in 2005?
Offer a very short reply. 1.09. What is the ratio of the Value added (% of GDP) in Manufacturing in 2001 to that in 2005?
Your response must be concise. 1.17. What is the ratio of the Value added (% of GDP) of Services in 2001 to that in 2005?
Provide a succinct answer. 0.96. What is the ratio of the Value added (% of GDP) of Agriculture in 2001 to that in 2005?
Ensure brevity in your answer.  1.22. What is the ratio of the Value added (% of GDP) of Industry in 2001 to that in 2006?
Offer a very short reply. 0.96. What is the ratio of the Value added (% of GDP) in Manufacturing in 2001 to that in 2006?
Your answer should be very brief. 1.17. What is the ratio of the Value added (% of GDP) of Services in 2001 to that in 2006?
Offer a very short reply. 0.98. What is the ratio of the Value added (% of GDP) of Agriculture in 2001 to that in 2006?
Provide a short and direct response. 1.62. What is the ratio of the Value added (% of GDP) of Industry in 2002 to that in 2003?
Your answer should be very brief. 0.95. What is the ratio of the Value added (% of GDP) of Manufacturing in 2002 to that in 2003?
Your response must be concise. 1.08. What is the ratio of the Value added (% of GDP) of Services in 2002 to that in 2003?
Keep it short and to the point. 1.01. What is the ratio of the Value added (% of GDP) of Agriculture in 2002 to that in 2003?
Offer a terse response. 1. What is the ratio of the Value added (% of GDP) in Industry in 2002 to that in 2004?
Offer a terse response. 0.97. What is the ratio of the Value added (% of GDP) of Manufacturing in 2002 to that in 2004?
Your answer should be very brief. 1.14. What is the ratio of the Value added (% of GDP) in Services in 2002 to that in 2004?
Make the answer very short. 1. What is the ratio of the Value added (% of GDP) in Agriculture in 2002 to that in 2004?
Your response must be concise. 1.18. What is the ratio of the Value added (% of GDP) of Industry in 2002 to that in 2005?
Offer a terse response. 1.1. What is the ratio of the Value added (% of GDP) in Manufacturing in 2002 to that in 2005?
Your answer should be very brief. 1.15. What is the ratio of the Value added (% of GDP) in Services in 2002 to that in 2005?
Keep it short and to the point. 0.96. What is the ratio of the Value added (% of GDP) of Agriculture in 2002 to that in 2005?
Give a very brief answer. 1.17. What is the ratio of the Value added (% of GDP) of Industry in 2002 to that in 2006?
Offer a very short reply. 0.97. What is the ratio of the Value added (% of GDP) of Manufacturing in 2002 to that in 2006?
Make the answer very short. 1.16. What is the ratio of the Value added (% of GDP) of Services in 2002 to that in 2006?
Your response must be concise. 0.98. What is the ratio of the Value added (% of GDP) in Agriculture in 2002 to that in 2006?
Provide a short and direct response. 1.55. What is the ratio of the Value added (% of GDP) in Industry in 2003 to that in 2004?
Make the answer very short. 1.01. What is the ratio of the Value added (% of GDP) of Manufacturing in 2003 to that in 2004?
Give a very brief answer. 1.05. What is the ratio of the Value added (% of GDP) of Services in 2003 to that in 2004?
Your answer should be very brief. 0.98. What is the ratio of the Value added (% of GDP) of Agriculture in 2003 to that in 2004?
Provide a short and direct response. 1.18. What is the ratio of the Value added (% of GDP) in Industry in 2003 to that in 2005?
Ensure brevity in your answer.  1.15. What is the ratio of the Value added (% of GDP) of Manufacturing in 2003 to that in 2005?
Provide a short and direct response. 1.07. What is the ratio of the Value added (% of GDP) of Services in 2003 to that in 2005?
Make the answer very short. 0.95. What is the ratio of the Value added (% of GDP) of Agriculture in 2003 to that in 2005?
Give a very brief answer. 1.17. What is the ratio of the Value added (% of GDP) in Industry in 2003 to that in 2006?
Provide a short and direct response. 1.01. What is the ratio of the Value added (% of GDP) of Manufacturing in 2003 to that in 2006?
Offer a very short reply. 1.07. What is the ratio of the Value added (% of GDP) in Services in 2003 to that in 2006?
Your answer should be compact. 0.97. What is the ratio of the Value added (% of GDP) of Agriculture in 2003 to that in 2006?
Your answer should be compact. 1.54. What is the ratio of the Value added (% of GDP) of Industry in 2004 to that in 2005?
Your answer should be very brief. 1.14. What is the ratio of the Value added (% of GDP) in Manufacturing in 2004 to that in 2005?
Your response must be concise. 1.01. What is the ratio of the Value added (% of GDP) of Services in 2004 to that in 2005?
Offer a terse response. 0.96. What is the ratio of the Value added (% of GDP) in Agriculture in 2004 to that in 2005?
Give a very brief answer. 0.99. What is the ratio of the Value added (% of GDP) in Industry in 2004 to that in 2006?
Offer a terse response. 1. What is the ratio of the Value added (% of GDP) in Manufacturing in 2004 to that in 2006?
Keep it short and to the point. 1.02. What is the ratio of the Value added (% of GDP) in Agriculture in 2004 to that in 2006?
Provide a succinct answer. 1.31. What is the ratio of the Value added (% of GDP) of Industry in 2005 to that in 2006?
Ensure brevity in your answer.  0.88. What is the ratio of the Value added (% of GDP) of Services in 2005 to that in 2006?
Keep it short and to the point. 1.02. What is the ratio of the Value added (% of GDP) of Agriculture in 2005 to that in 2006?
Your answer should be very brief. 1.32. What is the difference between the highest and the second highest Value added (% of GDP) of Industry?
Your response must be concise. 0.31. What is the difference between the highest and the second highest Value added (% of GDP) of Manufacturing?
Your answer should be compact. 0.14. What is the difference between the highest and the second highest Value added (% of GDP) in Services?
Ensure brevity in your answer.  1.56. What is the difference between the highest and the second highest Value added (% of GDP) in Agriculture?
Your answer should be very brief. 0.25. What is the difference between the highest and the lowest Value added (% of GDP) in Industry?
Give a very brief answer. 3.03. What is the difference between the highest and the lowest Value added (% of GDP) of Manufacturing?
Ensure brevity in your answer.  1.62. What is the difference between the highest and the lowest Value added (% of GDP) of Services?
Make the answer very short. 3.83. What is the difference between the highest and the lowest Value added (% of GDP) of Agriculture?
Your response must be concise. 2.48. 